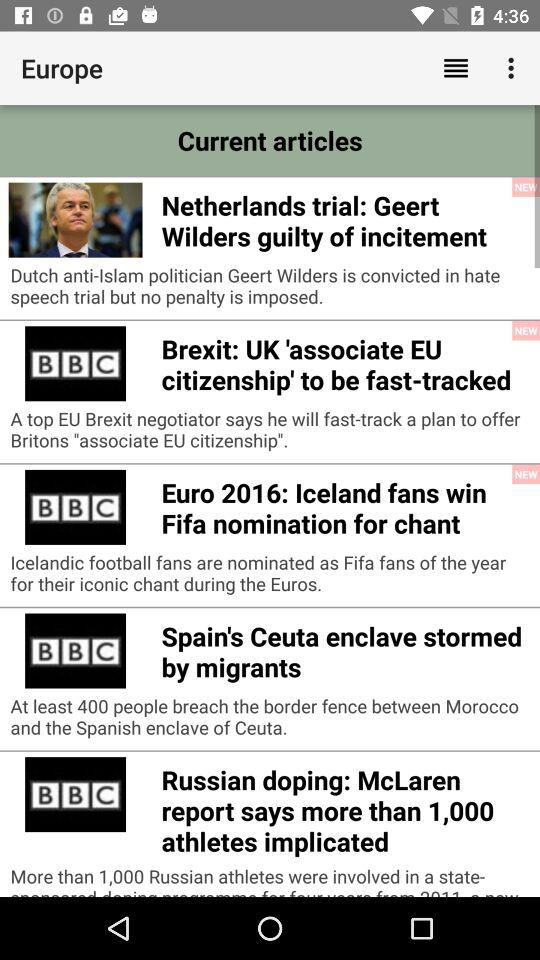How many people have breached the border fence between Morocco and the Spanish enclave of Ceuta? There are at least 400 people who have breached the border fence between Morocco and the Spanish enclave of Ceuta. 